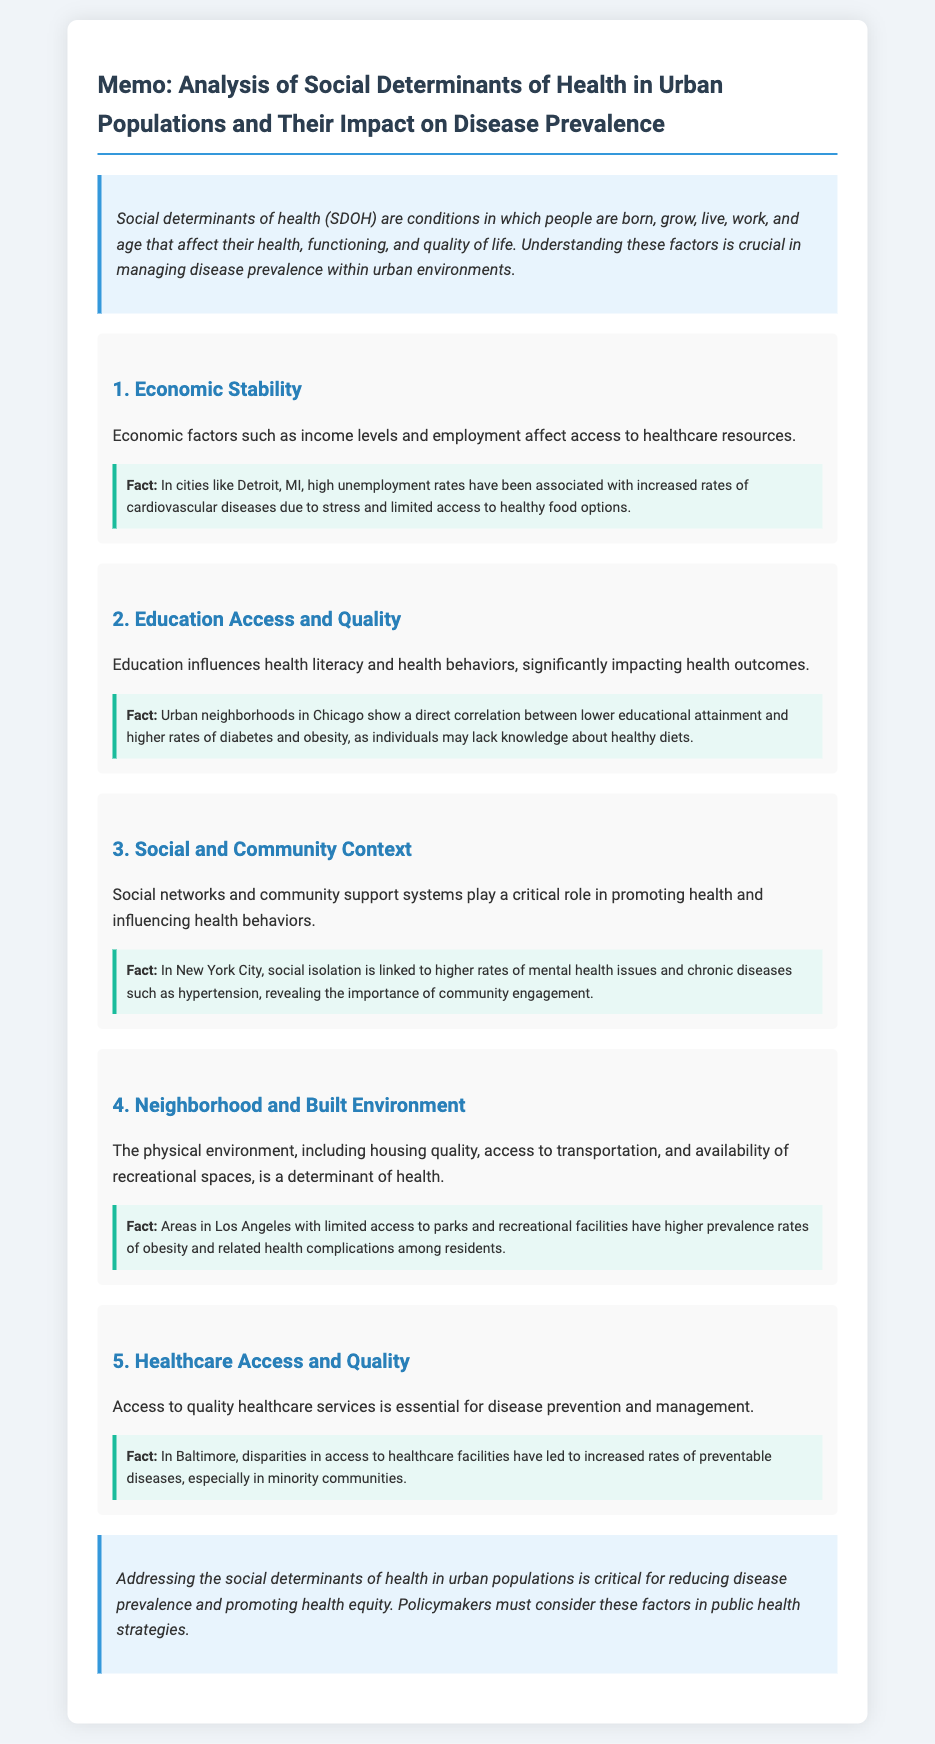What are social determinants of health? Social determinants of health are conditions in which people are born, grow, live, work, and age that affect their health, functioning, and quality of life.
Answer: Conditions in which people are born, grow, live, work, and age What economic factor affects healthcare access? The memo mentions that economic factors such as income levels and employment affect access to healthcare resources.
Answer: Income levels and employment Which urban area is mentioned in relation to educational attainment and health outcomes? The memo provides information about urban neighborhoods in Chicago regarding educational attainment and health outcomes.
Answer: Chicago What is the correlation noted in New York City regarding health? The document states that social isolation is linked to higher rates of mental health issues and chronic diseases such as hypertension.
Answer: Higher rates of mental health issues and chronic diseases What issue is highlighted about Baltimore in terms of healthcare? The memo indicates that disparities in access to healthcare facilities have led to increased rates of preventable diseases, especially in minority communities.
Answer: Increased rates of preventable diseases How does neighborhood environment impact health according to the memo? The section highlights that limited access to parks and recreational facilities correlates with higher prevalence rates of obesity.
Answer: Higher prevalence rates of obesity What is the primary recommendation for policymakers? The conclusion states that policymakers should consider social determinants of health in public health strategies to address health equity.
Answer: Consider social determinants of health in public health strategies What role do social networks play in urban health? The memo notes that social networks and community support systems promote health and influence health behaviors.
Answer: Promote health and influence health behaviors 